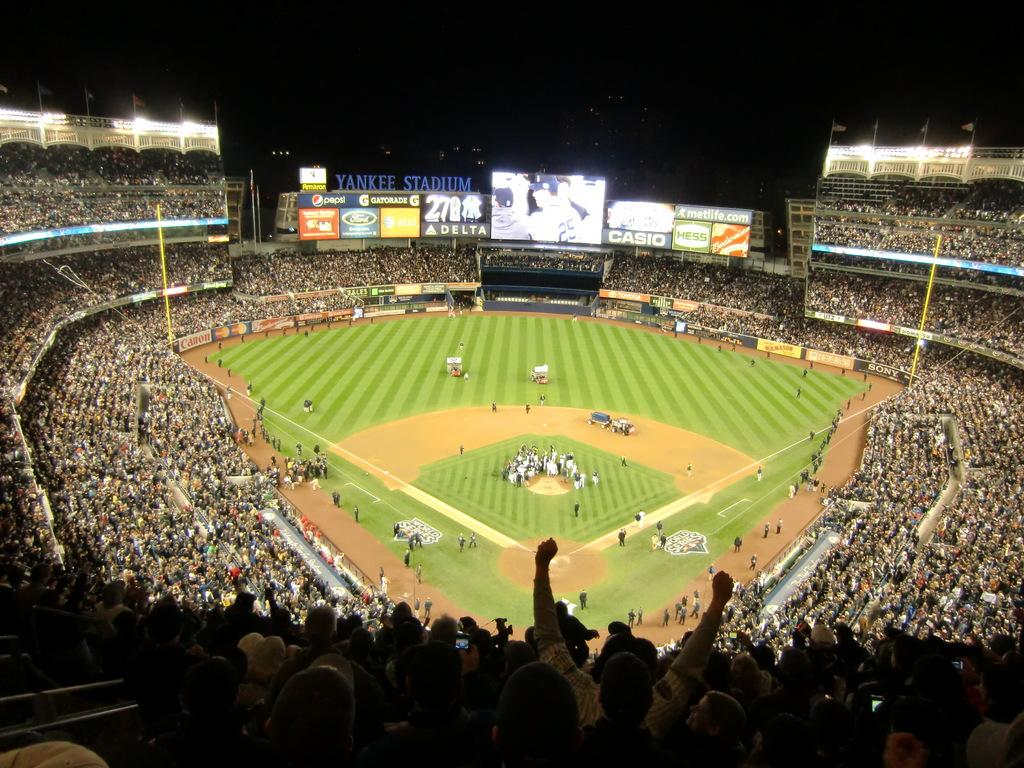Provide a one-sentence caption for the provided image. Huge blue lettering identifies a crowded sports arena as Yankee Stadium. 